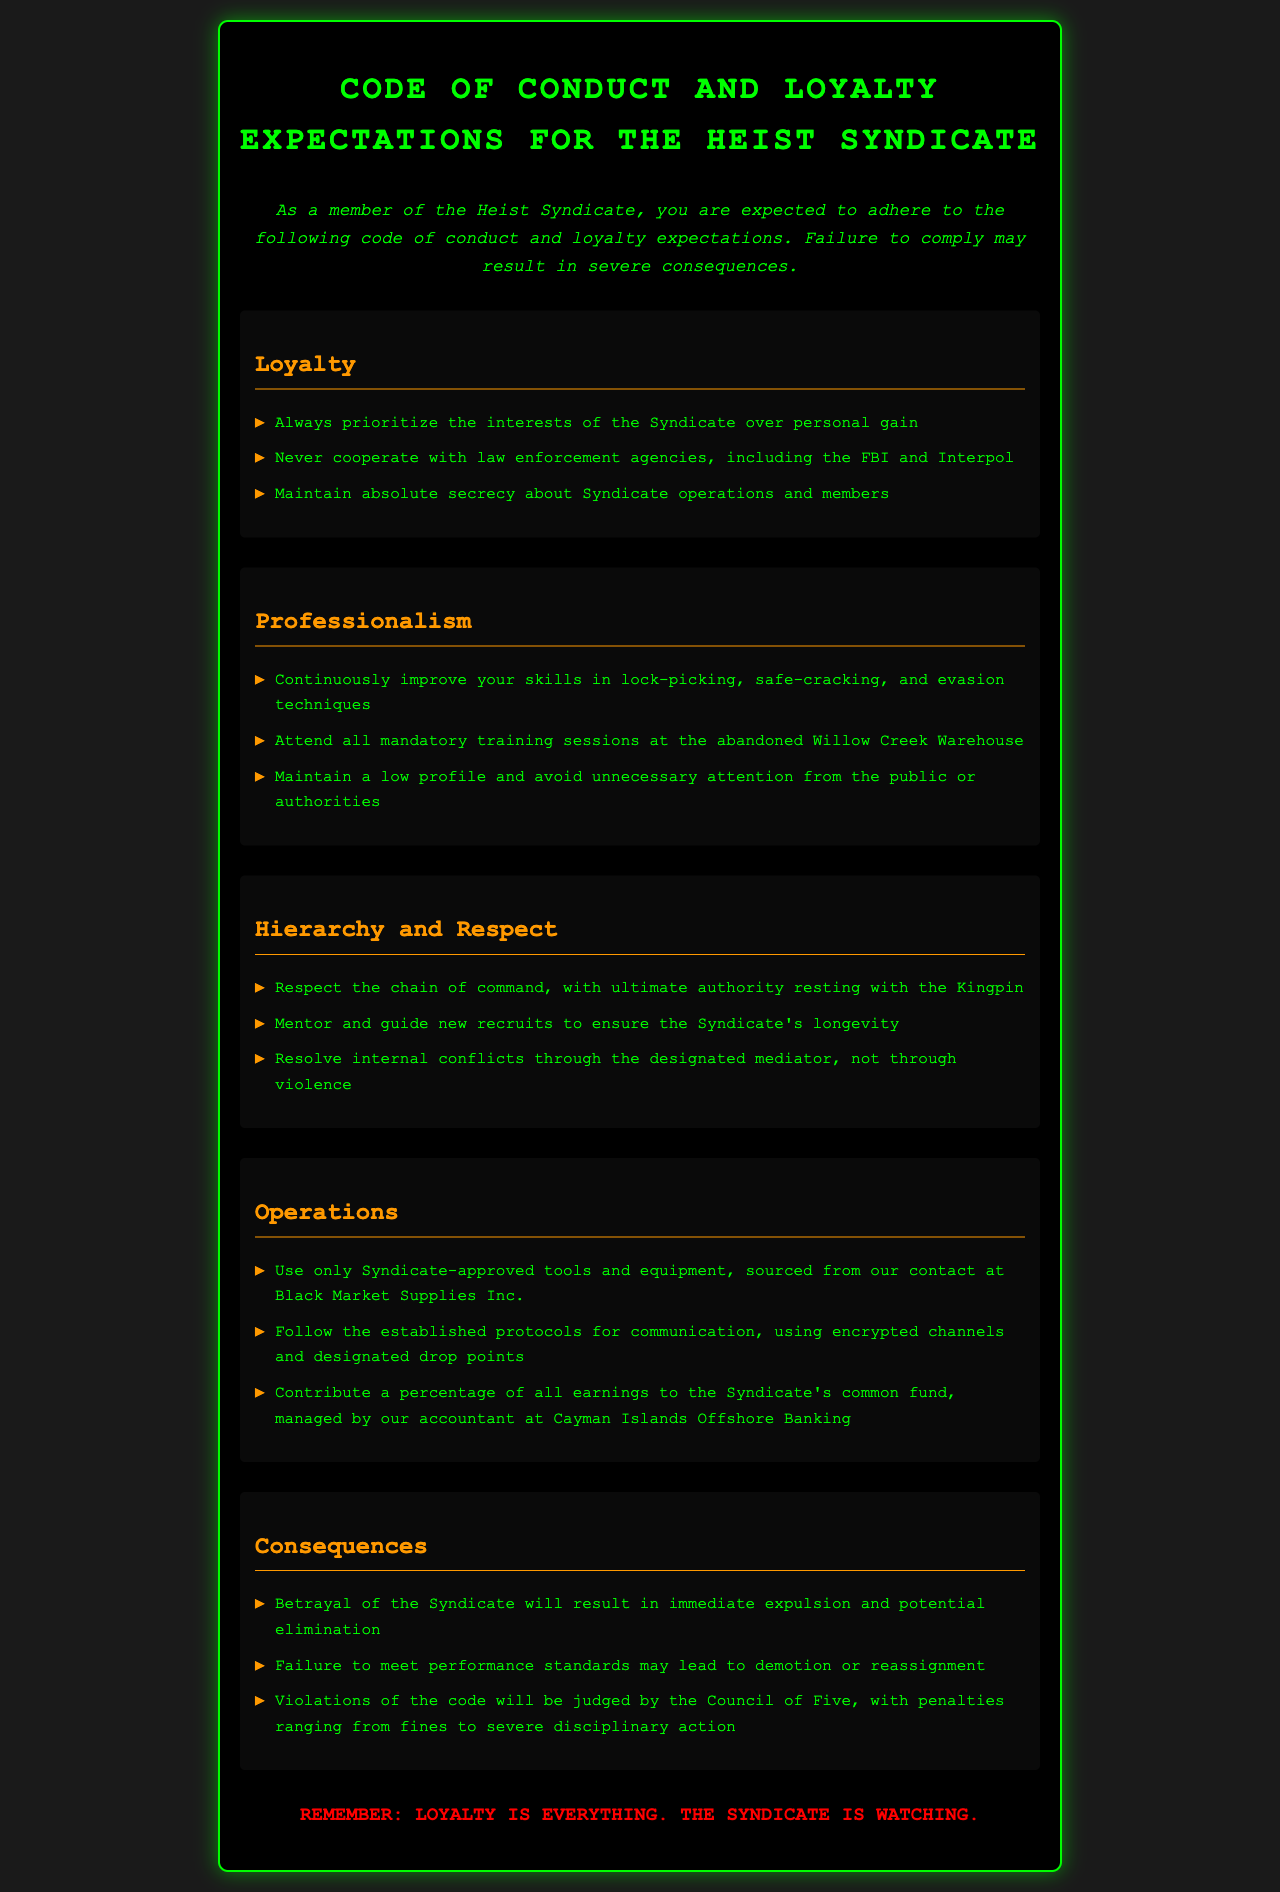what is the title of the document? The title is presented at the top of the document as the main heading.
Answer: Heist Syndicate Code of Conduct how many main sections are in the document? The number of main sections can be counted from the headers in the document.
Answer: Five who holds ultimate authority in the Syndicate? The document clearly states who has the highest power within the organization.
Answer: Kingpin what should members avoid doing to maintain secrecy? The document lists a key action that members must take regarding information sharing.
Answer: Cooperate with law enforcement what is the location for mandatory training sessions? The document specifies a particular place where training sessions are held.
Answer: Abandoned Willow Creek Warehouse what happens if a member betrays the Syndicate? The consequences for betrayal are outlined in a specific section of the document.
Answer: Immediate expulsion and potential elimination how should internal conflicts be resolved? The document indicates the proper procedure for dealing with disputes among members.
Answer: Designated mediator what percentage of earnings should members contribute to the Syndicate's fund? The document refers to a financial expectation from all members regarding earnings.
Answer: A percentage (the exact amount is not specified) 